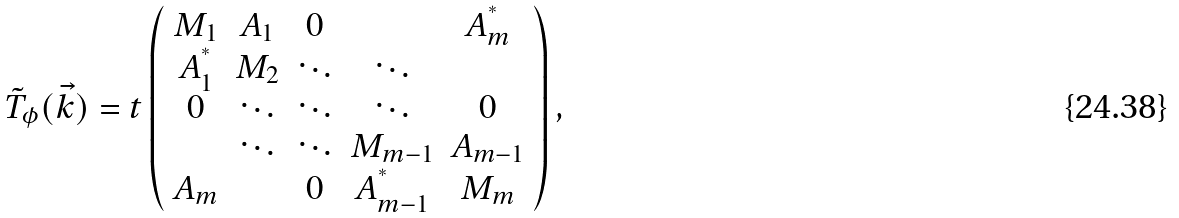<formula> <loc_0><loc_0><loc_500><loc_500>\tilde { T } _ { \phi } ( \vec { k } ) = t \left ( \begin{array} { c c c c c } M _ { 1 } & A _ { 1 } & 0 & & A _ { m } ^ { ^ { * } } \\ A _ { 1 } ^ { ^ { * } } & M _ { 2 } & \ddots & \ddots & \\ 0 & \ddots & \ddots & \ddots & 0 \\ & \ddots & \ddots & M _ { m - 1 } & A _ { m - 1 } \\ A _ { m } & & 0 & A _ { m - 1 } ^ { ^ { * } } & M _ { m } \end{array} \right ) ,</formula> 